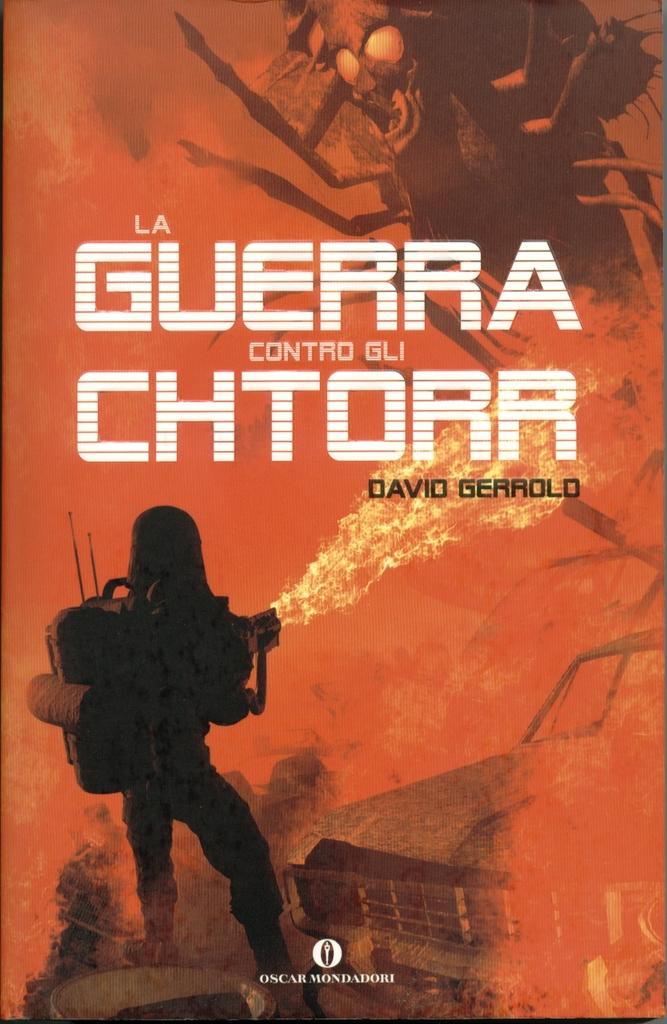Who wrote this book?
Provide a succinct answer. David gerrold. What is the title of this book?
Provide a succinct answer. La guerra contro gli chtorr. 